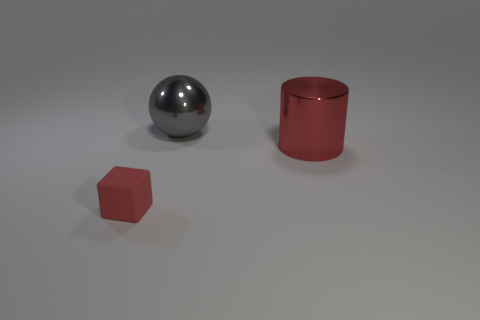Is there anything else that has the same size as the red block?
Your response must be concise. No. Does the red thing that is to the left of the gray metallic sphere have the same size as the large metallic sphere?
Ensure brevity in your answer.  No. What is the size of the red metal thing?
Offer a terse response. Large. Is there a large shiny cylinder that has the same color as the big metallic sphere?
Offer a terse response. No. What number of small objects are red matte things or metallic cylinders?
Offer a very short reply. 1. There is a object that is both in front of the gray object and to the left of the red metal cylinder; how big is it?
Offer a terse response. Small. What number of tiny cubes are on the left side of the tiny object?
Offer a very short reply. 0. There is a thing that is left of the big cylinder and in front of the gray sphere; what shape is it?
Your answer should be very brief. Cube. There is a tiny cube that is the same color as the large cylinder; what is its material?
Keep it short and to the point. Rubber. How many blocks are either big gray objects or red things?
Keep it short and to the point. 1. 